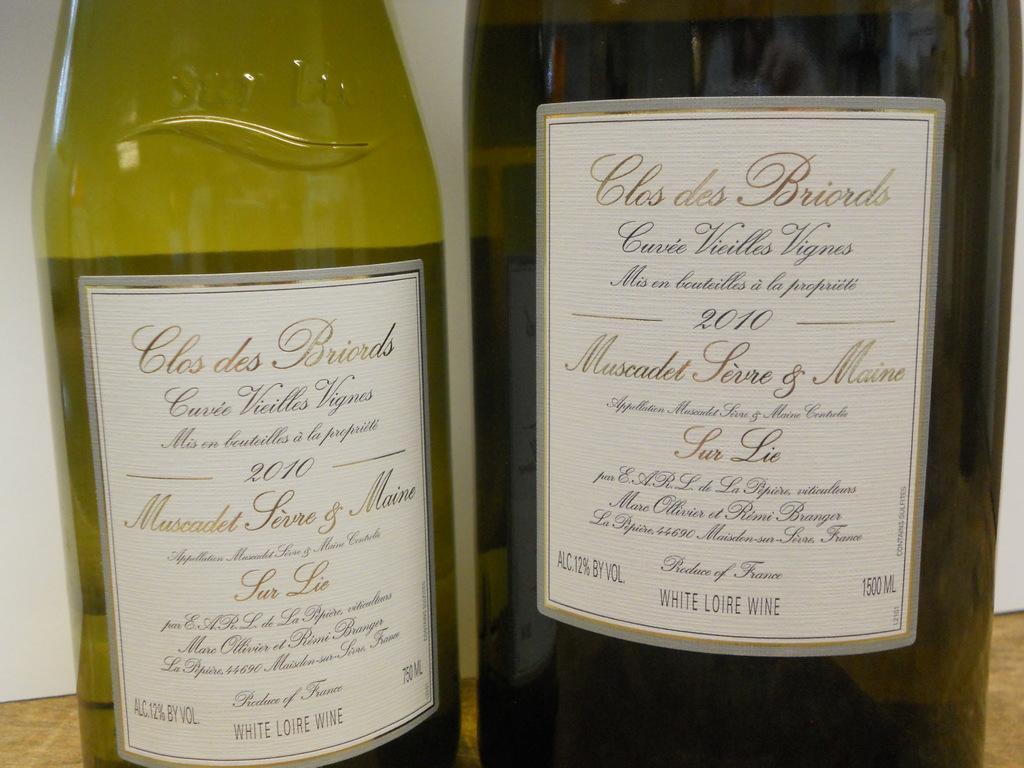Could you give a brief overview of what you see in this image? Two wine bottles on a table. 